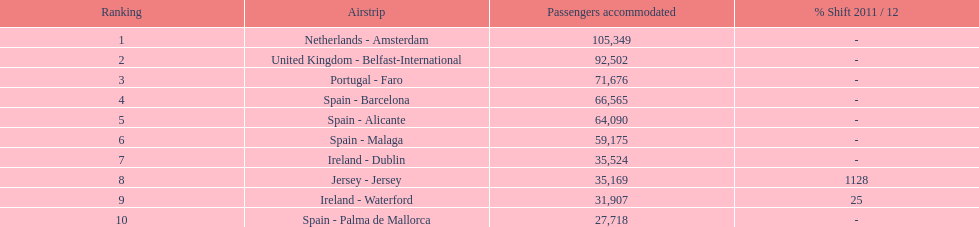Can you give me this table as a dict? {'header': ['Ranking', 'Airstrip', 'Passengers accommodated', '% Shift 2011 / 12'], 'rows': [['1', 'Netherlands - Amsterdam', '105,349', '-'], ['2', 'United Kingdom - Belfast-International', '92,502', '-'], ['3', 'Portugal - Faro', '71,676', '-'], ['4', 'Spain - Barcelona', '66,565', '-'], ['5', 'Spain - Alicante', '64,090', '-'], ['6', 'Spain - Malaga', '59,175', '-'], ['7', 'Ireland - Dublin', '35,524', '-'], ['8', 'Jersey - Jersey', '35,169', '1128'], ['9', 'Ireland - Waterford', '31,907', '25'], ['10', 'Spain - Palma de Mallorca', '27,718', '-']]} Which airport has the least amount of passengers going through london southend airport? Spain - Palma de Mallorca. 